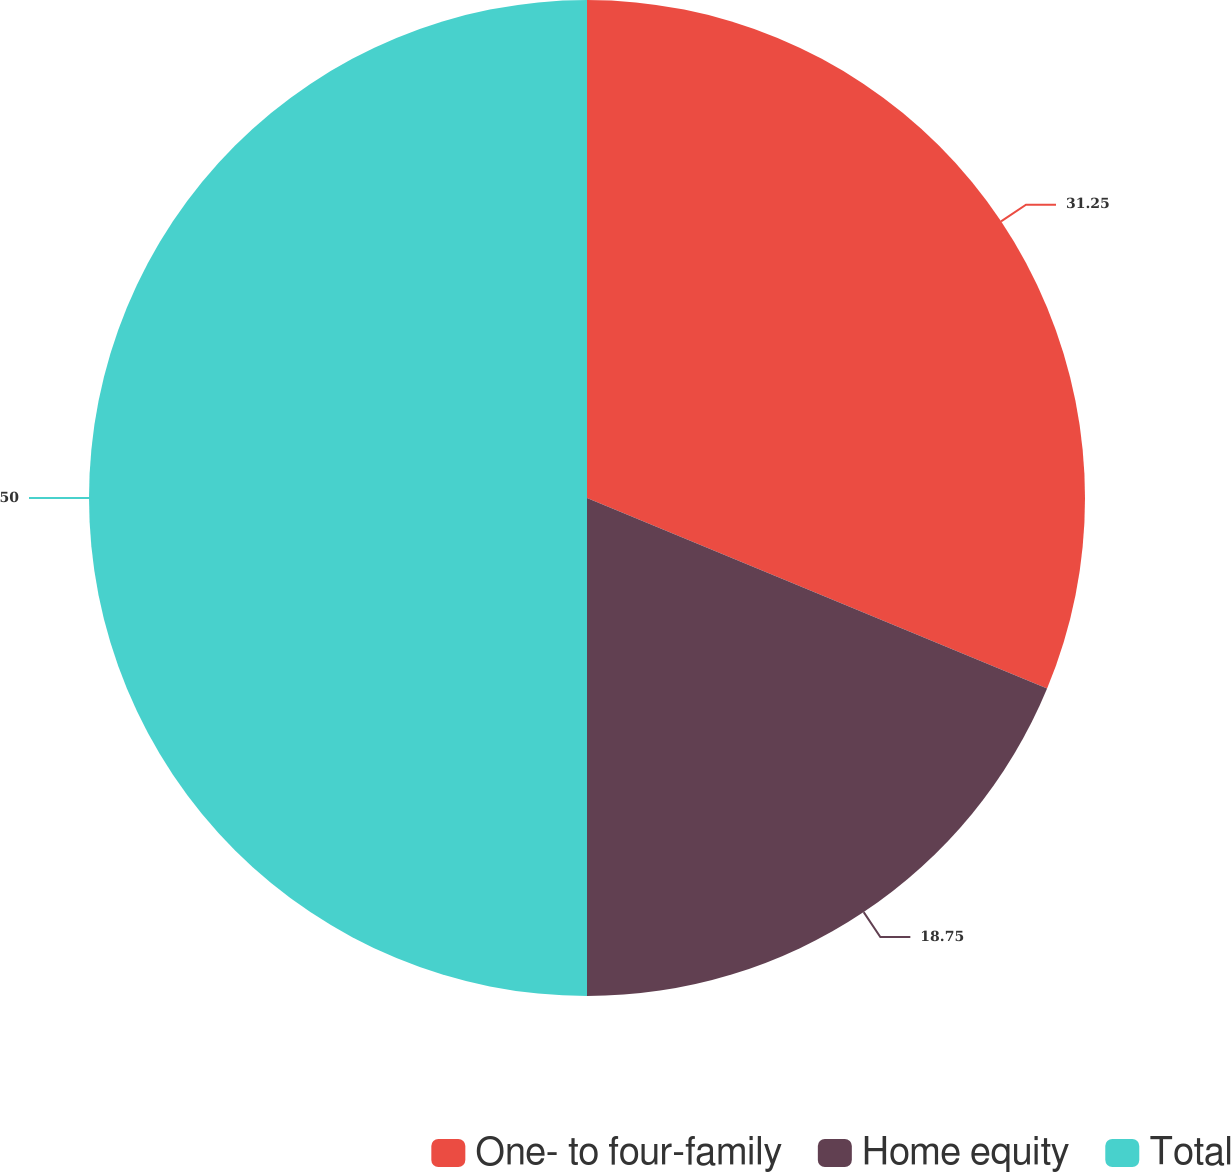Convert chart to OTSL. <chart><loc_0><loc_0><loc_500><loc_500><pie_chart><fcel>One- to four-family<fcel>Home equity<fcel>Total<nl><fcel>31.25%<fcel>18.75%<fcel>50.0%<nl></chart> 